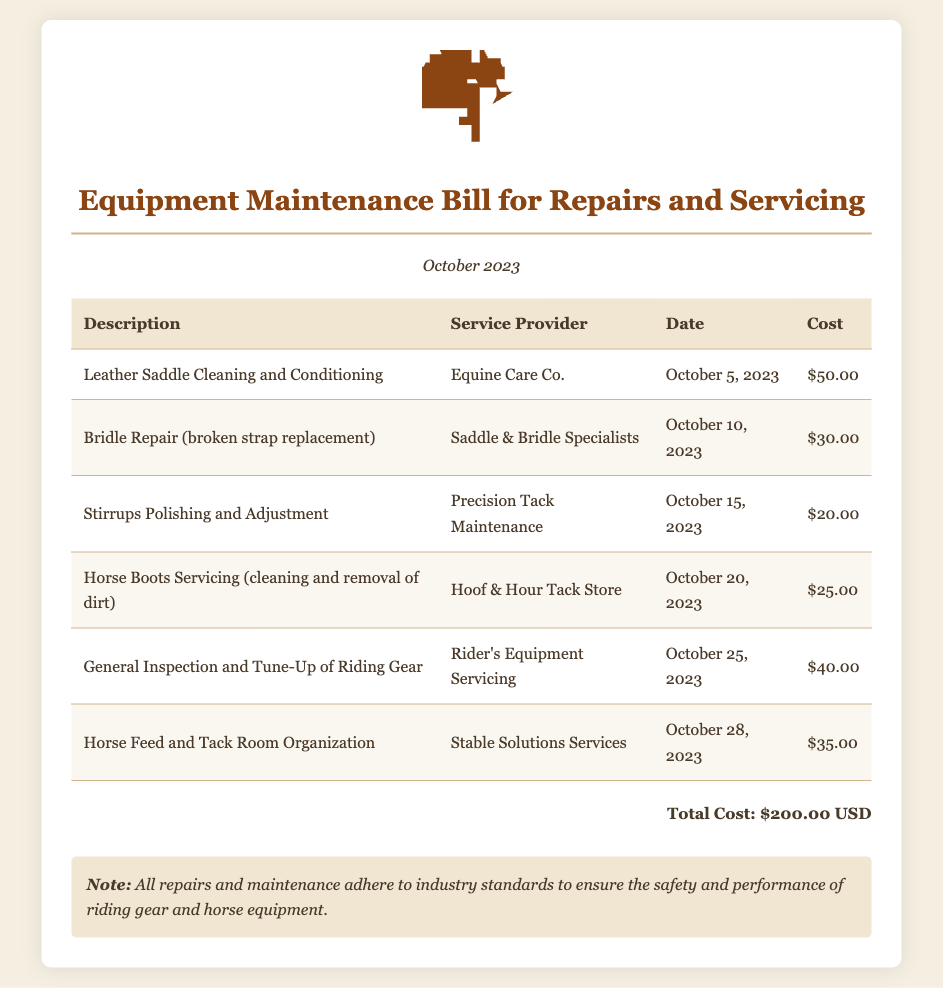What is the total cost of the maintenance bill? The total cost is mentioned at the end of the document, summing all individual costs listed.
Answer: $200.00 USD Who provided the leather saddle cleaning and conditioning service? The service provider is stated next to the description of the service.
Answer: Equine Care Co What date was the bridle repair completed? The date is presented in the corresponding row under the "Date" column for the specific service.
Answer: October 10, 2023 How much did the stirrups polishing and adjustment cost? The cost is clearly stated next to the description of the service in the table.
Answer: $20.00 Which service had the highest cost? This requires the comparison of all listed costs to find the highest one.
Answer: $50.00 What is the note mentioned at the bottom of the bill? The note explains the adherence to industry standards for repairs and maintenance.
Answer: All repairs and maintenance adhere to industry standards to ensure the safety and performance of riding gear and horse equipment How many services were provided in total? This is determined by counting the number of entries in the service list.
Answer: 6 What was the date for the general inspection and tune-up of riding gear? The date for this service is provided in the respective row of the table.
Answer: October 25, 2023 Who provided the horse feed and tack room organization service? The service provider is listed alongside the service description in the table.
Answer: Stable Solutions Services 